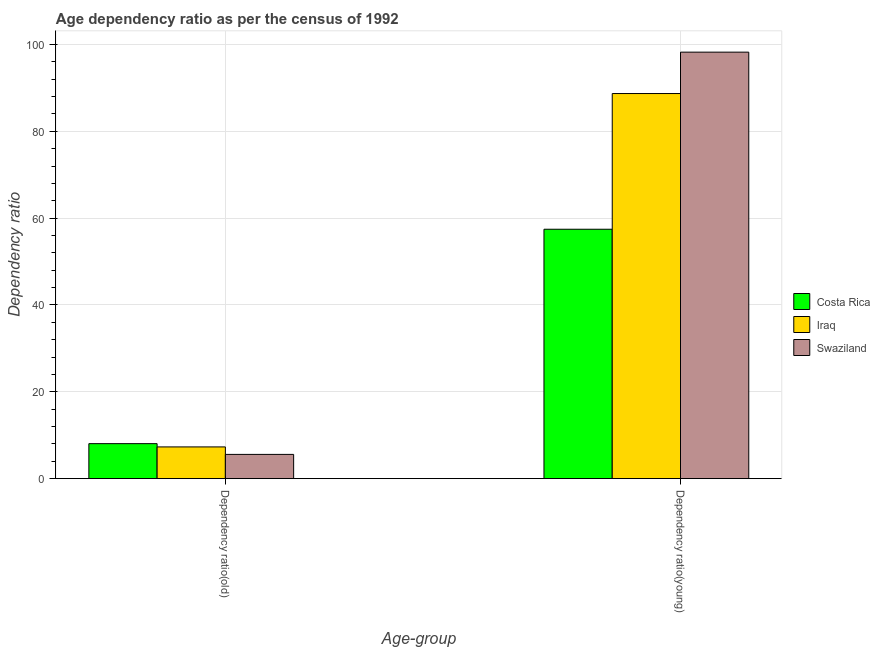How many groups of bars are there?
Provide a short and direct response. 2. Are the number of bars per tick equal to the number of legend labels?
Ensure brevity in your answer.  Yes. How many bars are there on the 1st tick from the left?
Provide a succinct answer. 3. What is the label of the 1st group of bars from the left?
Ensure brevity in your answer.  Dependency ratio(old). What is the age dependency ratio(old) in Swaziland?
Make the answer very short. 5.58. Across all countries, what is the maximum age dependency ratio(old)?
Your answer should be compact. 8.05. Across all countries, what is the minimum age dependency ratio(young)?
Your answer should be very brief. 57.45. In which country was the age dependency ratio(young) minimum?
Give a very brief answer. Costa Rica. What is the total age dependency ratio(young) in the graph?
Provide a succinct answer. 244.4. What is the difference between the age dependency ratio(old) in Swaziland and that in Costa Rica?
Your answer should be very brief. -2.48. What is the difference between the age dependency ratio(old) in Iraq and the age dependency ratio(young) in Costa Rica?
Give a very brief answer. -50.15. What is the average age dependency ratio(young) per country?
Keep it short and to the point. 81.47. What is the difference between the age dependency ratio(young) and age dependency ratio(old) in Iraq?
Keep it short and to the point. 81.41. In how many countries, is the age dependency ratio(old) greater than 80 ?
Your answer should be very brief. 0. What is the ratio of the age dependency ratio(young) in Swaziland to that in Costa Rica?
Offer a very short reply. 1.71. Is the age dependency ratio(young) in Swaziland less than that in Iraq?
Provide a succinct answer. No. What does the 2nd bar from the left in Dependency ratio(young) represents?
Offer a terse response. Iraq. What does the 2nd bar from the right in Dependency ratio(young) represents?
Your answer should be very brief. Iraq. How many bars are there?
Make the answer very short. 6. Are the values on the major ticks of Y-axis written in scientific E-notation?
Ensure brevity in your answer.  No. Does the graph contain grids?
Provide a succinct answer. Yes. Where does the legend appear in the graph?
Offer a terse response. Center right. How are the legend labels stacked?
Your answer should be compact. Vertical. What is the title of the graph?
Offer a very short reply. Age dependency ratio as per the census of 1992. What is the label or title of the X-axis?
Offer a terse response. Age-group. What is the label or title of the Y-axis?
Give a very brief answer. Dependency ratio. What is the Dependency ratio in Costa Rica in Dependency ratio(old)?
Offer a very short reply. 8.05. What is the Dependency ratio in Iraq in Dependency ratio(old)?
Your answer should be compact. 7.3. What is the Dependency ratio in Swaziland in Dependency ratio(old)?
Provide a succinct answer. 5.58. What is the Dependency ratio of Costa Rica in Dependency ratio(young)?
Offer a terse response. 57.45. What is the Dependency ratio of Iraq in Dependency ratio(young)?
Your answer should be very brief. 88.71. What is the Dependency ratio in Swaziland in Dependency ratio(young)?
Your answer should be compact. 98.24. Across all Age-group, what is the maximum Dependency ratio of Costa Rica?
Provide a succinct answer. 57.45. Across all Age-group, what is the maximum Dependency ratio of Iraq?
Provide a short and direct response. 88.71. Across all Age-group, what is the maximum Dependency ratio of Swaziland?
Provide a succinct answer. 98.24. Across all Age-group, what is the minimum Dependency ratio of Costa Rica?
Your response must be concise. 8.05. Across all Age-group, what is the minimum Dependency ratio of Iraq?
Provide a short and direct response. 7.3. Across all Age-group, what is the minimum Dependency ratio of Swaziland?
Provide a short and direct response. 5.58. What is the total Dependency ratio of Costa Rica in the graph?
Your answer should be compact. 65.5. What is the total Dependency ratio in Iraq in the graph?
Provide a succinct answer. 96.01. What is the total Dependency ratio of Swaziland in the graph?
Give a very brief answer. 103.82. What is the difference between the Dependency ratio of Costa Rica in Dependency ratio(old) and that in Dependency ratio(young)?
Offer a terse response. -49.39. What is the difference between the Dependency ratio of Iraq in Dependency ratio(old) and that in Dependency ratio(young)?
Make the answer very short. -81.41. What is the difference between the Dependency ratio in Swaziland in Dependency ratio(old) and that in Dependency ratio(young)?
Offer a terse response. -92.67. What is the difference between the Dependency ratio in Costa Rica in Dependency ratio(old) and the Dependency ratio in Iraq in Dependency ratio(young)?
Keep it short and to the point. -80.65. What is the difference between the Dependency ratio of Costa Rica in Dependency ratio(old) and the Dependency ratio of Swaziland in Dependency ratio(young)?
Provide a short and direct response. -90.19. What is the difference between the Dependency ratio in Iraq in Dependency ratio(old) and the Dependency ratio in Swaziland in Dependency ratio(young)?
Make the answer very short. -90.94. What is the average Dependency ratio in Costa Rica per Age-group?
Offer a very short reply. 32.75. What is the average Dependency ratio of Iraq per Age-group?
Your response must be concise. 48. What is the average Dependency ratio of Swaziland per Age-group?
Keep it short and to the point. 51.91. What is the difference between the Dependency ratio in Costa Rica and Dependency ratio in Iraq in Dependency ratio(old)?
Ensure brevity in your answer.  0.75. What is the difference between the Dependency ratio of Costa Rica and Dependency ratio of Swaziland in Dependency ratio(old)?
Your answer should be compact. 2.48. What is the difference between the Dependency ratio in Iraq and Dependency ratio in Swaziland in Dependency ratio(old)?
Provide a short and direct response. 1.72. What is the difference between the Dependency ratio in Costa Rica and Dependency ratio in Iraq in Dependency ratio(young)?
Your answer should be very brief. -31.26. What is the difference between the Dependency ratio in Costa Rica and Dependency ratio in Swaziland in Dependency ratio(young)?
Provide a succinct answer. -40.8. What is the difference between the Dependency ratio of Iraq and Dependency ratio of Swaziland in Dependency ratio(young)?
Provide a short and direct response. -9.54. What is the ratio of the Dependency ratio in Costa Rica in Dependency ratio(old) to that in Dependency ratio(young)?
Provide a succinct answer. 0.14. What is the ratio of the Dependency ratio in Iraq in Dependency ratio(old) to that in Dependency ratio(young)?
Make the answer very short. 0.08. What is the ratio of the Dependency ratio in Swaziland in Dependency ratio(old) to that in Dependency ratio(young)?
Offer a very short reply. 0.06. What is the difference between the highest and the second highest Dependency ratio of Costa Rica?
Ensure brevity in your answer.  49.39. What is the difference between the highest and the second highest Dependency ratio of Iraq?
Your answer should be compact. 81.41. What is the difference between the highest and the second highest Dependency ratio in Swaziland?
Make the answer very short. 92.67. What is the difference between the highest and the lowest Dependency ratio in Costa Rica?
Provide a succinct answer. 49.39. What is the difference between the highest and the lowest Dependency ratio of Iraq?
Offer a terse response. 81.41. What is the difference between the highest and the lowest Dependency ratio of Swaziland?
Offer a very short reply. 92.67. 